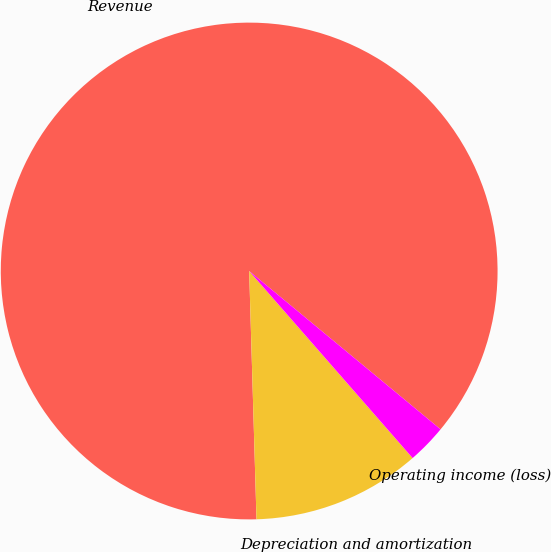Convert chart. <chart><loc_0><loc_0><loc_500><loc_500><pie_chart><fcel>Revenue<fcel>Depreciation and amortization<fcel>Operating income (loss)<nl><fcel>86.47%<fcel>10.96%<fcel>2.57%<nl></chart> 